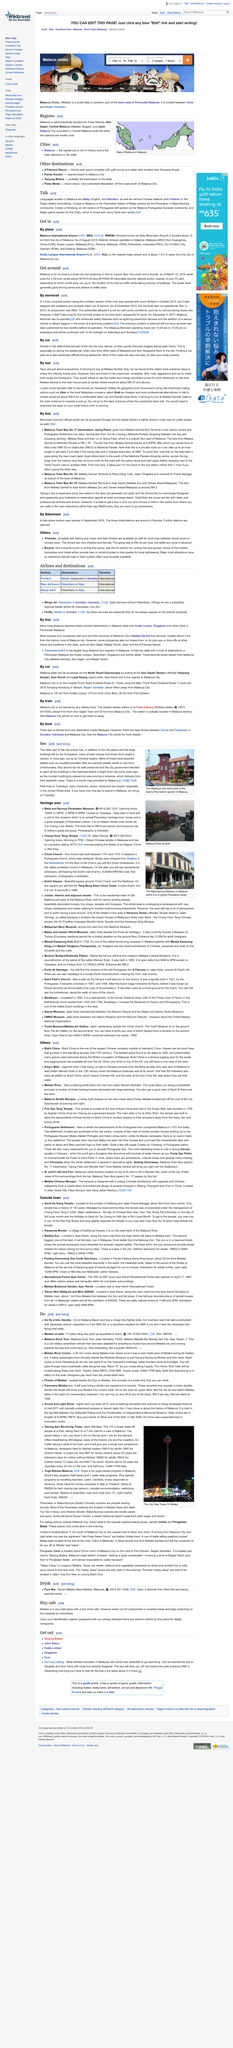Point out several critical features in this image. Melaka is the Malay name for Malacca, a historic city located in the western part of Malaysia. Christ Church was built between 1741 and 1753. It was called Christ Church at that time. The author of the opinion believes that the drivers of Malacca are good drivers. Information regarding the available transport methods is provided, including details on traveling by car and taxi. For tourists visiting Malacca, two excellent methods of transportation are walking and biking. 